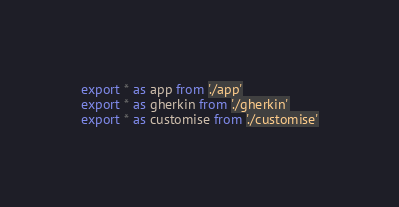<code> <loc_0><loc_0><loc_500><loc_500><_TypeScript_>export * as app from './app'
export * as gherkin from './gherkin'
export * as customise from './customise'
</code> 